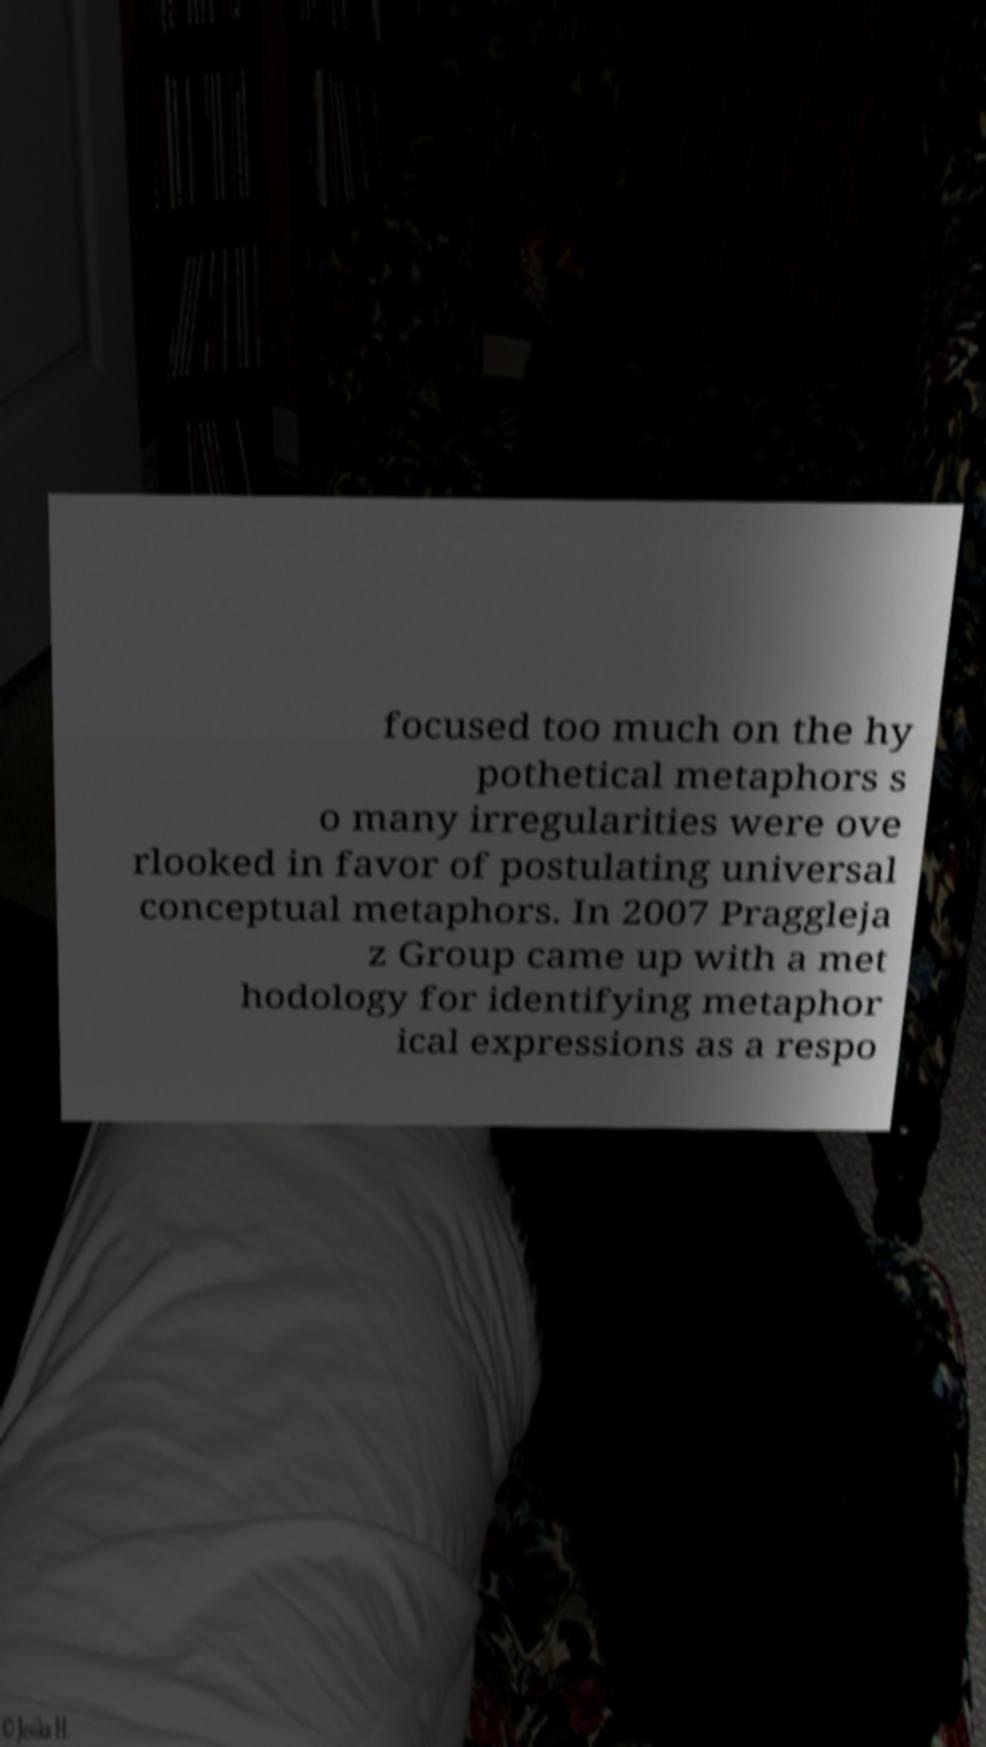Could you assist in decoding the text presented in this image and type it out clearly? focused too much on the hy pothetical metaphors s o many irregularities were ove rlooked in favor of postulating universal conceptual metaphors. In 2007 Praggleja z Group came up with a met hodology for identifying metaphor ical expressions as a respo 